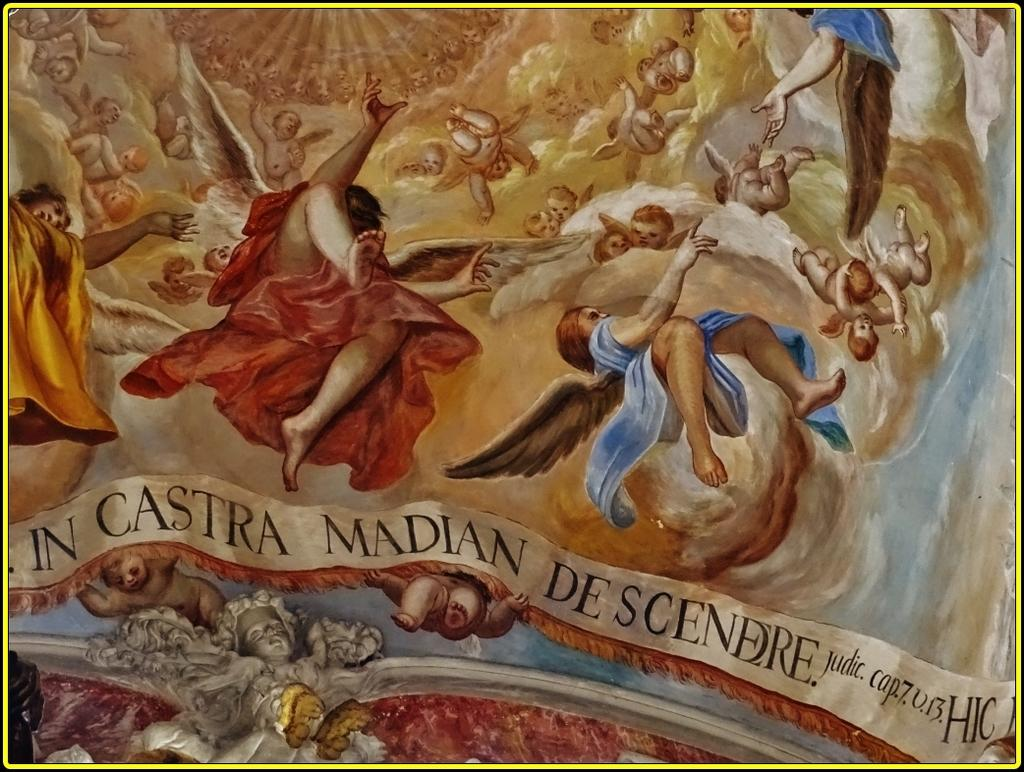What type of artwork is shown in the image? The image is a painting. What subjects are depicted in the painting? There are persons depicted in the painting. Are there any words or letters in the painting? Yes, there is text present in the painting. What type of flooring is visible in the painting? There is no flooring visible in the painting, as it is a painting of persons and text, not a scene with a floor. 